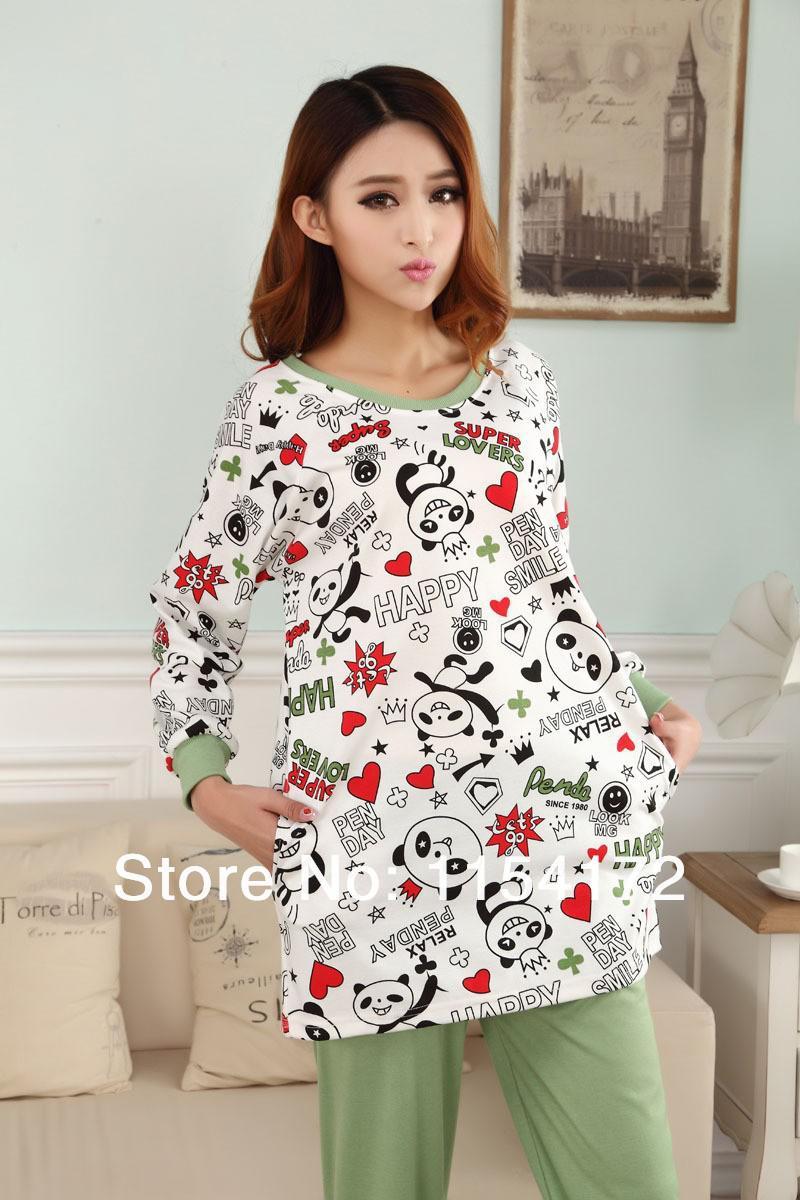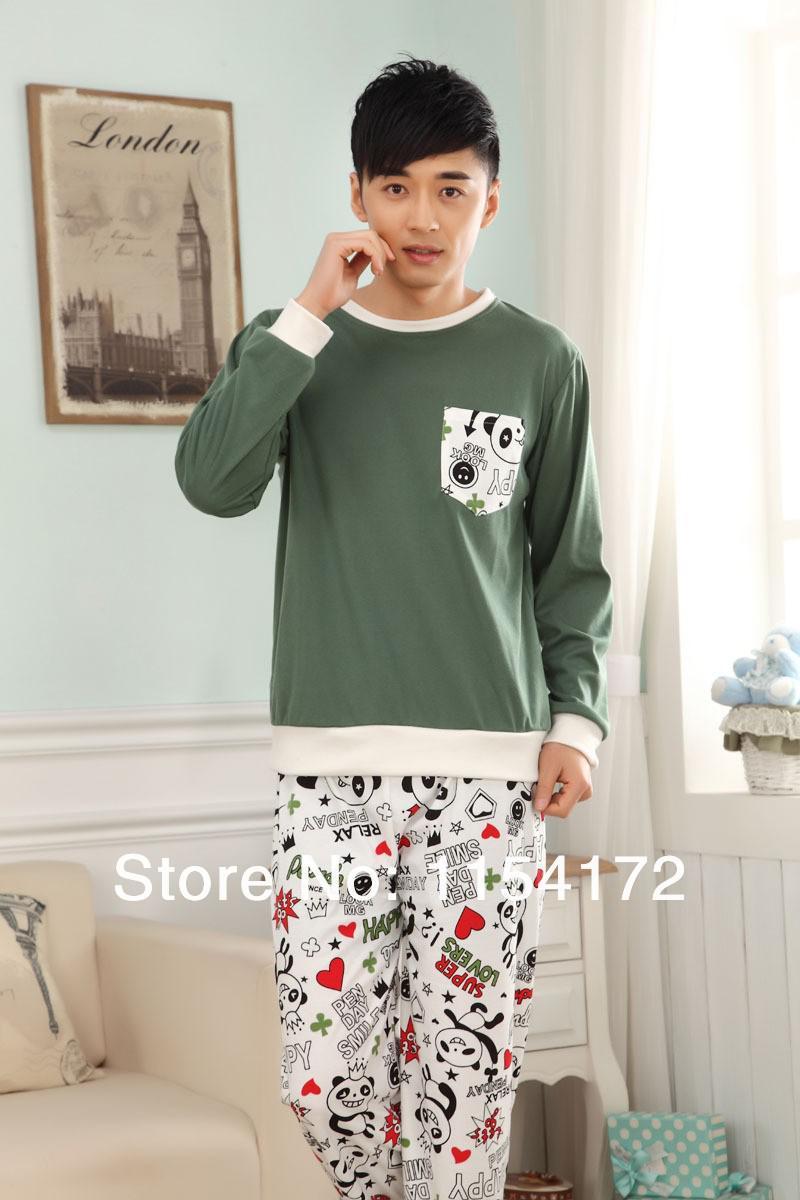The first image is the image on the left, the second image is the image on the right. Analyze the images presented: Is the assertion "Each image contains a man and a woman wearing matching clothing." valid? Answer yes or no. No. The first image is the image on the left, the second image is the image on the right. Assess this claim about the two images: "In one of the image the woman has her hood pulled up.". Correct or not? Answer yes or no. No. 